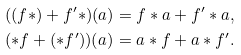<formula> <loc_0><loc_0><loc_500><loc_500>& ( ( f * ) + f ^ { \prime } * ) ( a ) = f * a + f ^ { \prime } * a , \\ & ( * f + ( * f ^ { \prime } ) ) ( a ) = a * f + a * f ^ { \prime } .</formula> 